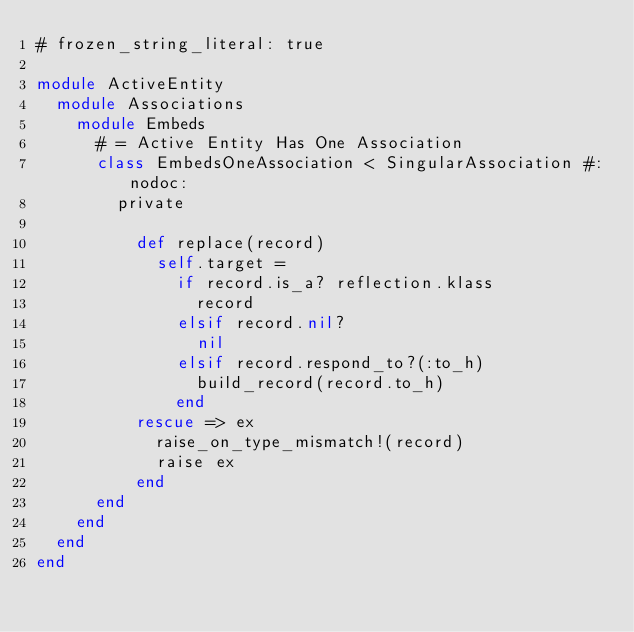Convert code to text. <code><loc_0><loc_0><loc_500><loc_500><_Ruby_># frozen_string_literal: true

module ActiveEntity
  module Associations
    module Embeds
      # = Active Entity Has One Association
      class EmbedsOneAssociation < SingularAssociation #:nodoc:
        private

          def replace(record)
            self.target =
              if record.is_a? reflection.klass
                record
              elsif record.nil?
                nil
              elsif record.respond_to?(:to_h)
                build_record(record.to_h)
              end
          rescue => ex
            raise_on_type_mismatch!(record)
            raise ex
          end
      end
    end
  end
end
</code> 